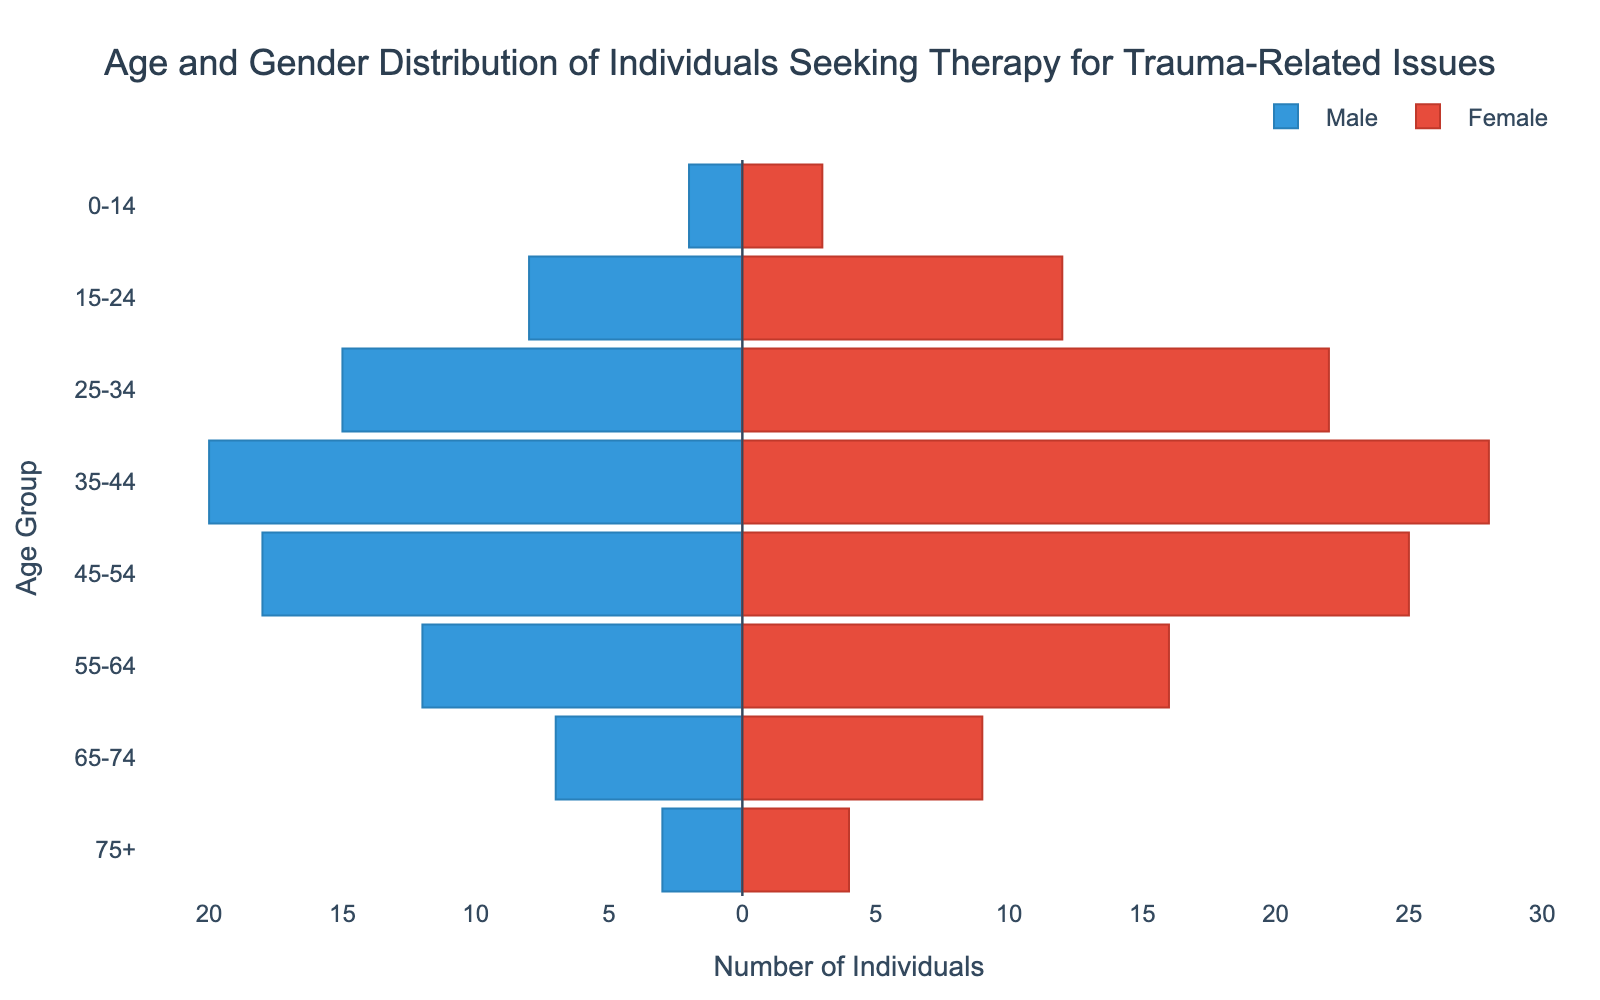How many age groups are shown in the figure? There are 8 distinct age groups listed on the y-axis of the figure. Each age group is represented horizontally.
Answer: 8 What is the title of the figure? The title is displayed at the top center of the figure.
Answer: Age and Gender Distribution of Individuals Seeking Therapy for Trauma-Related Issues In which age group are there the most females? By looking at the length of the bars on the right side, the 35-44 age group shows the longest bar for females.
Answer: 35-44 What is the difference between the number of males and females in the 25-34 age group? The number of males in the 25-34 age group is 15 and the number of females is 22. The difference is 22 - 15.
Answer: 7 Which age group has the fewest males seeking therapy? The smallest bar on the left side (negative x-axis) corresponds to the 0-14 age group.
Answer: 0-14 What is the combined total of individuals in the 45-54 age group? Add the absolute value of the male and female counts in the 45-54 age group: 18 (males) + 25 (females).
Answer: 43 How does the number of females in the 55-64 age group compare to the number of males in the same group? The number of females in this group is greater than the number of males, as the female bar is longer.
Answer: Females are greater Which age group has a nearly equal number of males and females seeking therapy? The 65-74 age group has numbers that are close, with 7 males and 9 females.
Answer: 65-74 What can you infer about the distribution pattern of individuals across different age groups? The distribution shows an increasing number of individuals seeking therapy with age, peaking around 35-44, before gradually decreasing in older age groups. This can be inferred from the longer bars in the middle age groups.
Answer: Peaks at 35-44 and decreases after 